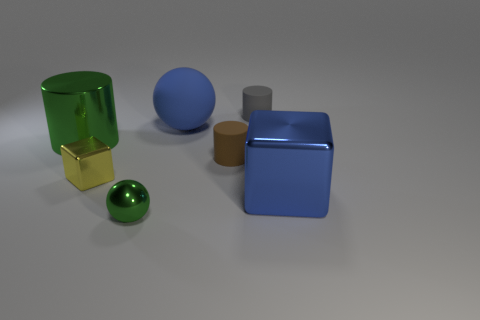There is a big object that is in front of the large shiny cylinder; does it have the same color as the large rubber ball?
Ensure brevity in your answer.  Yes. Are there any small cylinders that have the same material as the large blue sphere?
Offer a very short reply. Yes. There is a object that is the same color as the big metallic cube; what shape is it?
Your answer should be compact. Sphere. Is the number of brown cylinders to the left of the green sphere less than the number of tiny red balls?
Make the answer very short. No. Do the metal thing that is in front of the blue shiny thing and the tiny brown rubber cylinder have the same size?
Provide a succinct answer. Yes. What number of tiny yellow objects are the same shape as the gray rubber object?
Your response must be concise. 0. There is another block that is the same material as the big blue block; what size is it?
Make the answer very short. Small. Are there the same number of blue things that are in front of the small metal cube and big metal things?
Your answer should be compact. No. Do the rubber ball and the big metal block have the same color?
Offer a very short reply. Yes. There is a green object that is behind the small green object; is it the same shape as the tiny brown matte object that is on the right side of the green cylinder?
Give a very brief answer. Yes. 